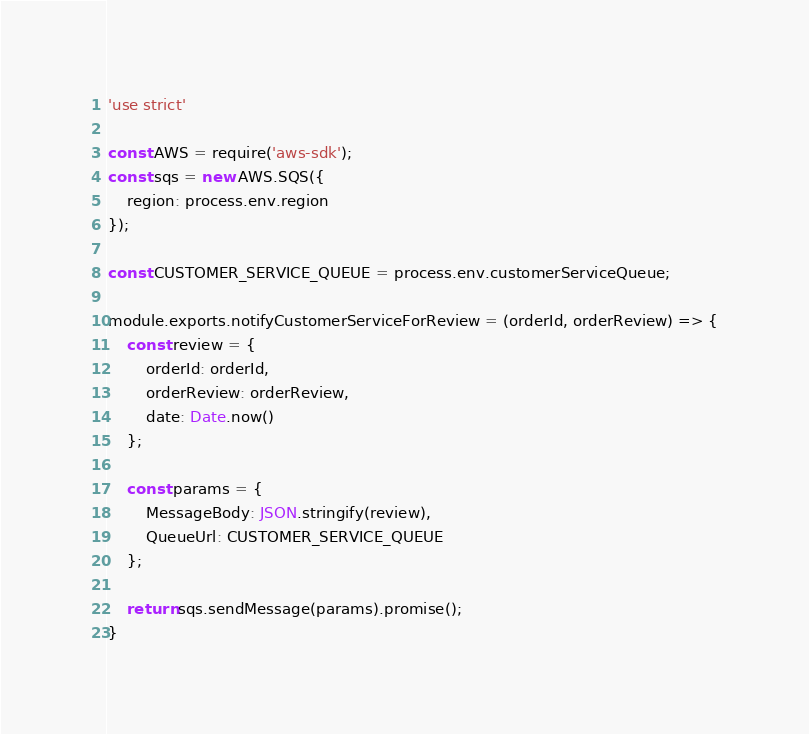Convert code to text. <code><loc_0><loc_0><loc_500><loc_500><_JavaScript_>'use strict'

const AWS = require('aws-sdk');
const sqs = new AWS.SQS({
    region: process.env.region
});

const CUSTOMER_SERVICE_QUEUE = process.env.customerServiceQueue;

module.exports.notifyCustomerServiceForReview = (orderId, orderReview) => {
    const review = {
        orderId: orderId,
        orderReview: orderReview,
        date: Date.now()
    };

    const params = {
        MessageBody: JSON.stringify(review),
        QueueUrl: CUSTOMER_SERVICE_QUEUE
    };

    return sqs.sendMessage(params).promise();
}</code> 